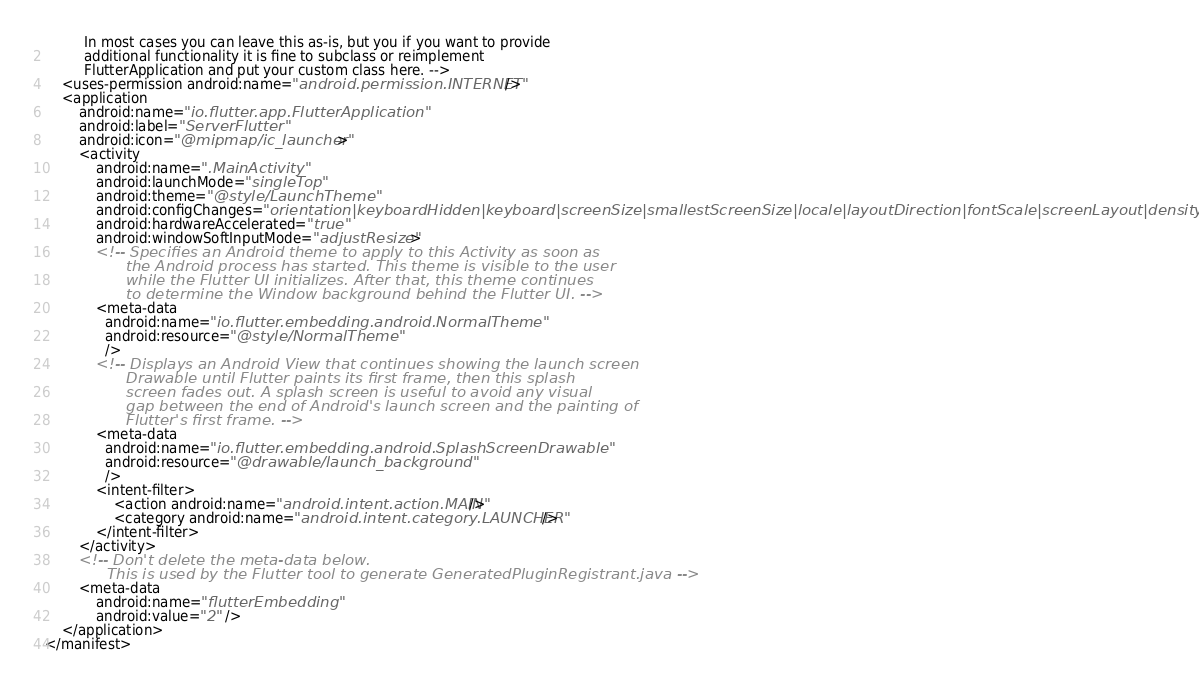<code> <loc_0><loc_0><loc_500><loc_500><_XML_>         In most cases you can leave this as-is, but you if you want to provide
         additional functionality it is fine to subclass or reimplement
         FlutterApplication and put your custom class here. -->
    <uses-permission android:name="android.permission.INTERNET"/>
    <application
        android:name="io.flutter.app.FlutterApplication"
        android:label="ServerFlutter"
        android:icon="@mipmap/ic_launcher">
        <activity
            android:name=".MainActivity"
            android:launchMode="singleTop"
            android:theme="@style/LaunchTheme"
            android:configChanges="orientation|keyboardHidden|keyboard|screenSize|smallestScreenSize|locale|layoutDirection|fontScale|screenLayout|density|uiMode"
            android:hardwareAccelerated="true"
            android:windowSoftInputMode="adjustResize">
            <!-- Specifies an Android theme to apply to this Activity as soon as
                 the Android process has started. This theme is visible to the user
                 while the Flutter UI initializes. After that, this theme continues
                 to determine the Window background behind the Flutter UI. -->
            <meta-data
              android:name="io.flutter.embedding.android.NormalTheme"
              android:resource="@style/NormalTheme"
              />
            <!-- Displays an Android View that continues showing the launch screen
                 Drawable until Flutter paints its first frame, then this splash
                 screen fades out. A splash screen is useful to avoid any visual
                 gap between the end of Android's launch screen and the painting of
                 Flutter's first frame. -->
            <meta-data
              android:name="io.flutter.embedding.android.SplashScreenDrawable"
              android:resource="@drawable/launch_background"
              />
            <intent-filter>
                <action android:name="android.intent.action.MAIN"/>
                <category android:name="android.intent.category.LAUNCHER"/>
            </intent-filter>
        </activity>
        <!-- Don't delete the meta-data below.
             This is used by the Flutter tool to generate GeneratedPluginRegistrant.java -->
        <meta-data
            android:name="flutterEmbedding"
            android:value="2" />
    </application>
</manifest></code> 